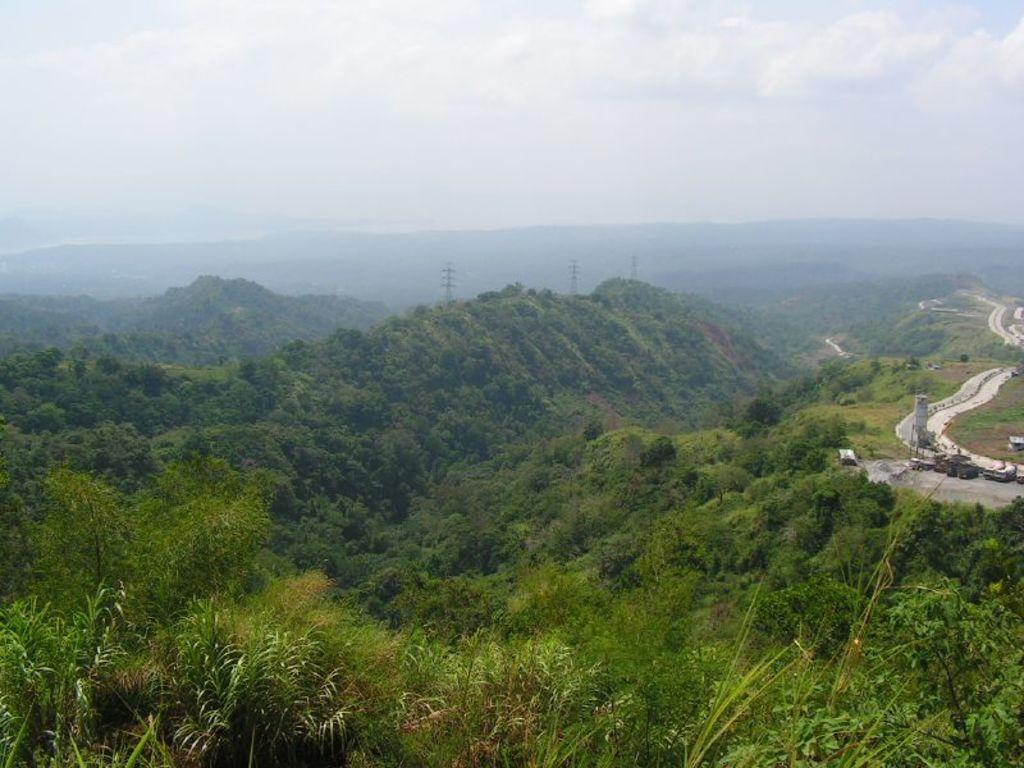Describe this image in one or two sentences. In this image I see the mountains and I see number of trees and plants over here and I see the path. In the background I see the sky. 